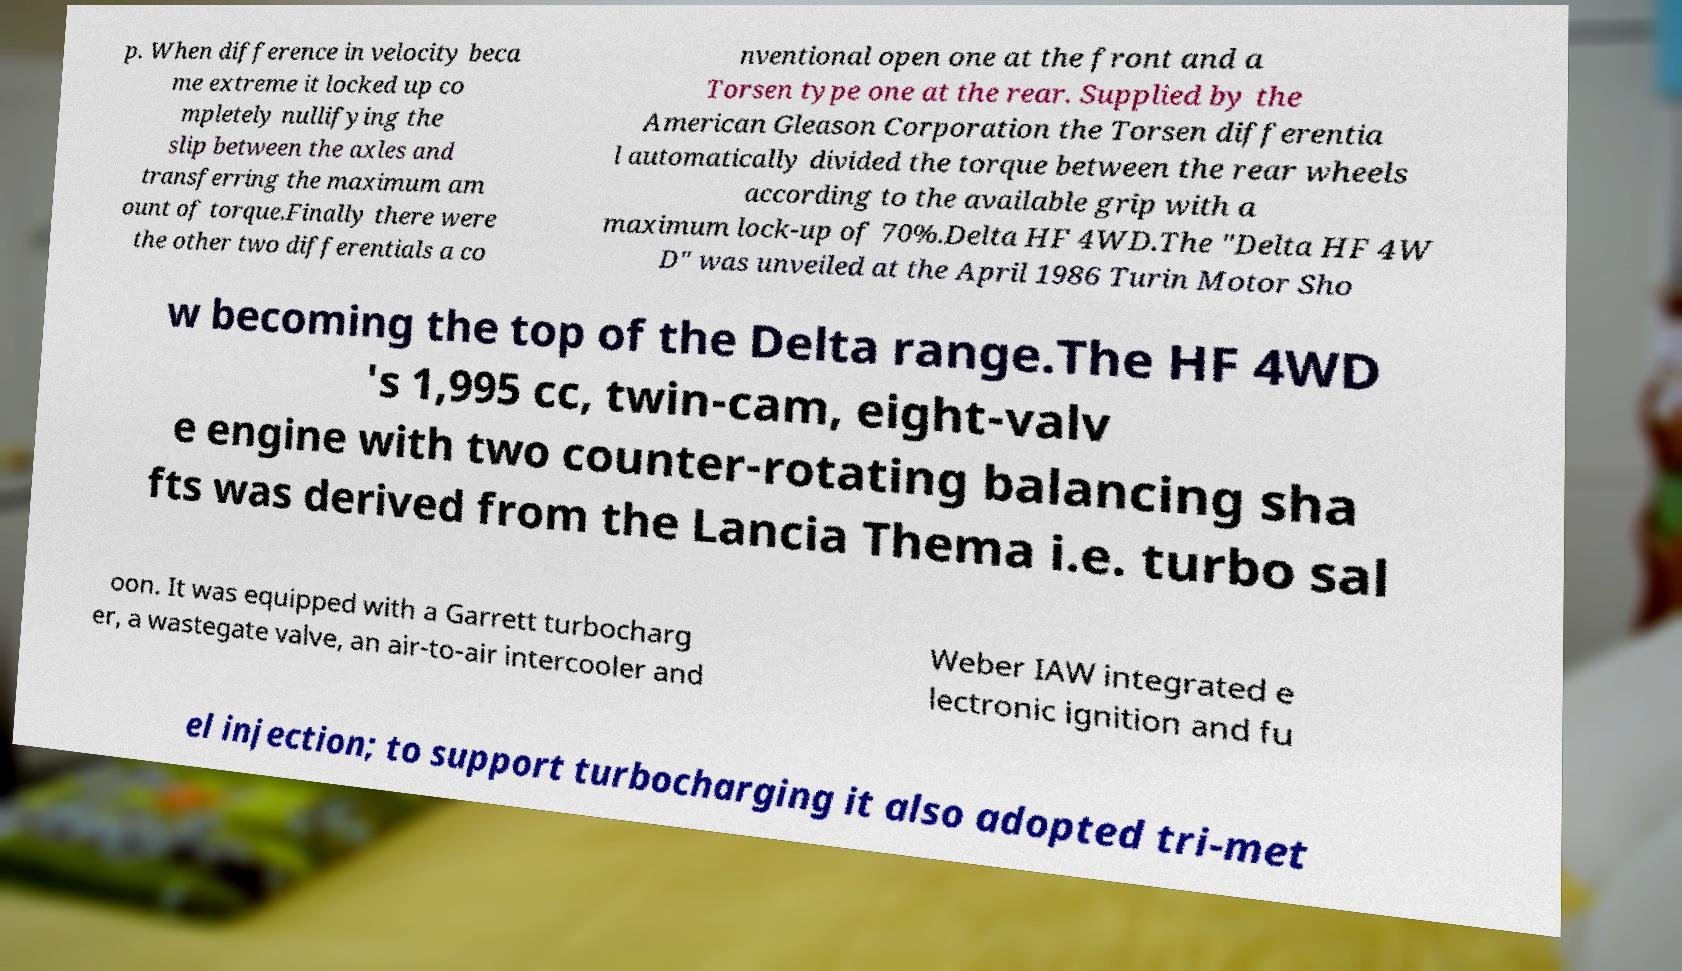Could you assist in decoding the text presented in this image and type it out clearly? p. When difference in velocity beca me extreme it locked up co mpletely nullifying the slip between the axles and transferring the maximum am ount of torque.Finally there were the other two differentials a co nventional open one at the front and a Torsen type one at the rear. Supplied by the American Gleason Corporation the Torsen differentia l automatically divided the torque between the rear wheels according to the available grip with a maximum lock-up of 70%.Delta HF 4WD.The "Delta HF 4W D" was unveiled at the April 1986 Turin Motor Sho w becoming the top of the Delta range.The HF 4WD 's 1,995 cc, twin-cam, eight-valv e engine with two counter-rotating balancing sha fts was derived from the Lancia Thema i.e. turbo sal oon. It was equipped with a Garrett turbocharg er, a wastegate valve, an air-to-air intercooler and Weber IAW integrated e lectronic ignition and fu el injection; to support turbocharging it also adopted tri-met 